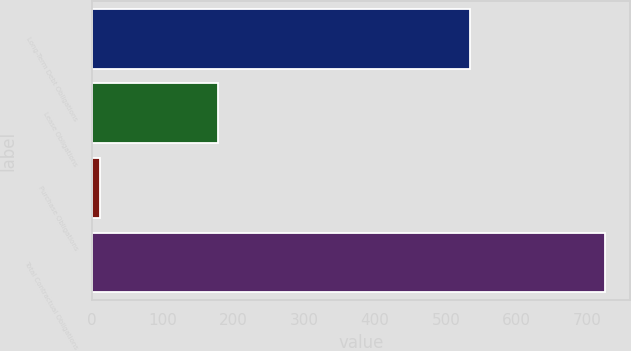<chart> <loc_0><loc_0><loc_500><loc_500><bar_chart><fcel>Long-Term Debt Obligations<fcel>Lease Obligations<fcel>Purchase Obligations<fcel>Total Contractual Obligations<nl><fcel>534<fcel>178<fcel>12<fcel>724<nl></chart> 